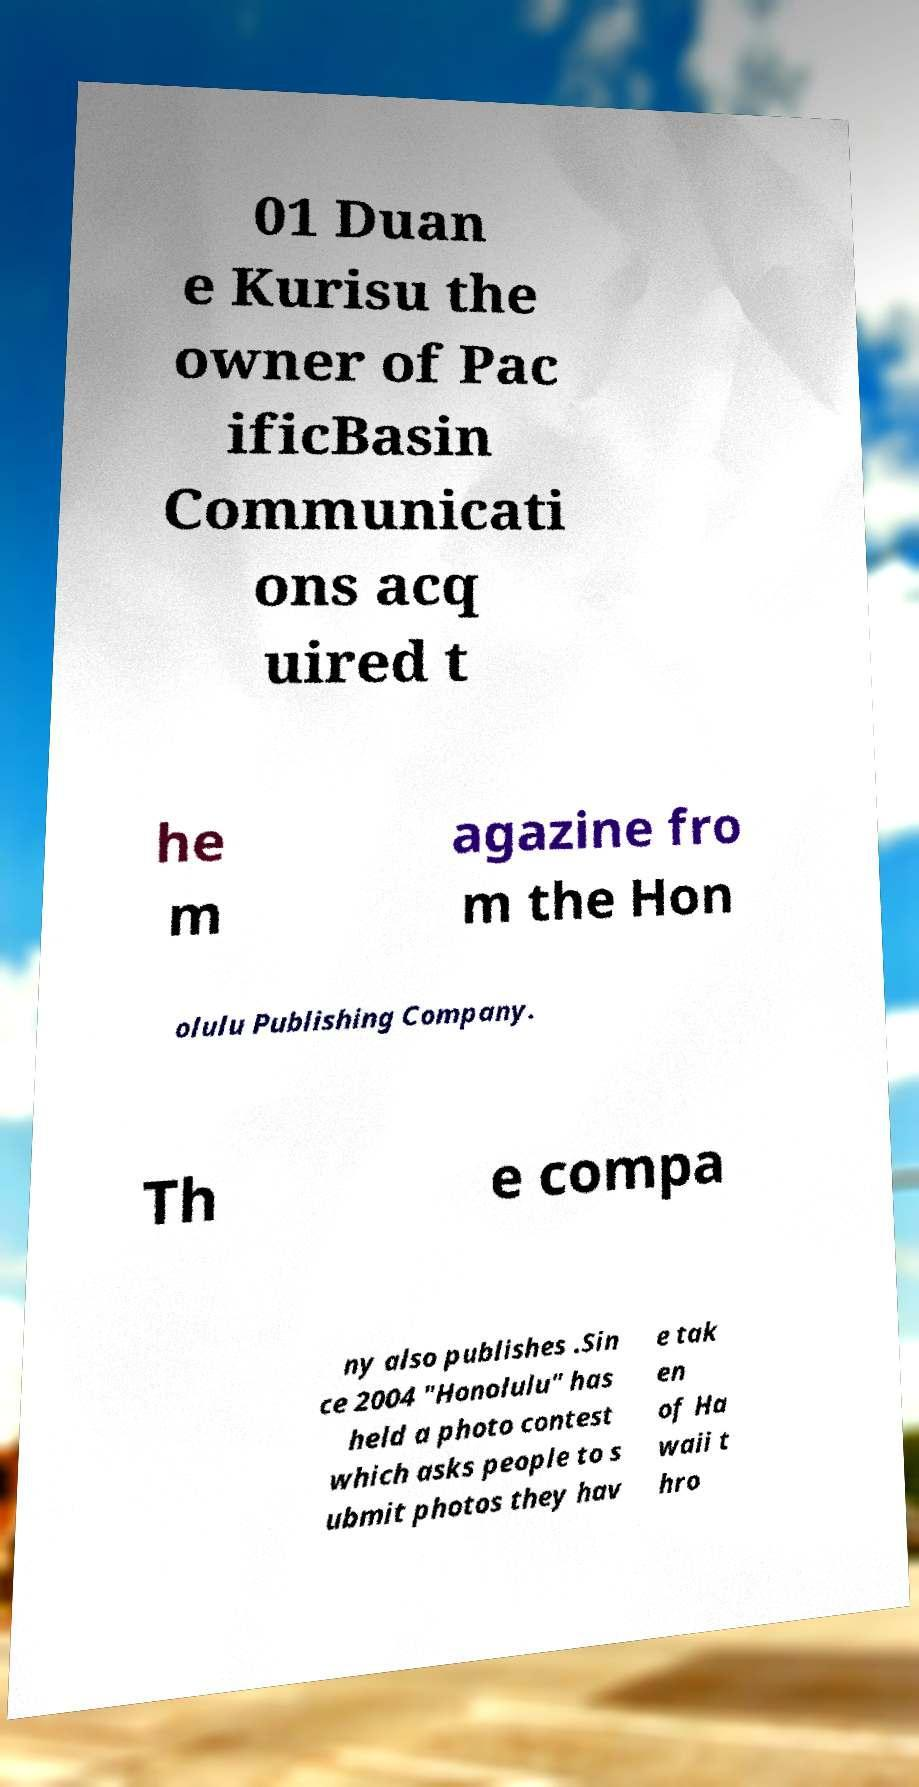Could you assist in decoding the text presented in this image and type it out clearly? 01 Duan e Kurisu the owner of Pac ificBasin Communicati ons acq uired t he m agazine fro m the Hon olulu Publishing Company. Th e compa ny also publishes .Sin ce 2004 "Honolulu" has held a photo contest which asks people to s ubmit photos they hav e tak en of Ha waii t hro 